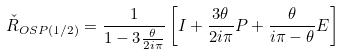Convert formula to latex. <formula><loc_0><loc_0><loc_500><loc_500>\check { R } _ { O S P ( 1 / 2 ) } = { \frac { 1 } { 1 - 3 { \frac { \theta } { 2 i \pi } } } } \left [ I + { \frac { 3 \theta } { 2 i \pi } } P + { \frac { \theta } { i \pi - \theta } } E \right ]</formula> 